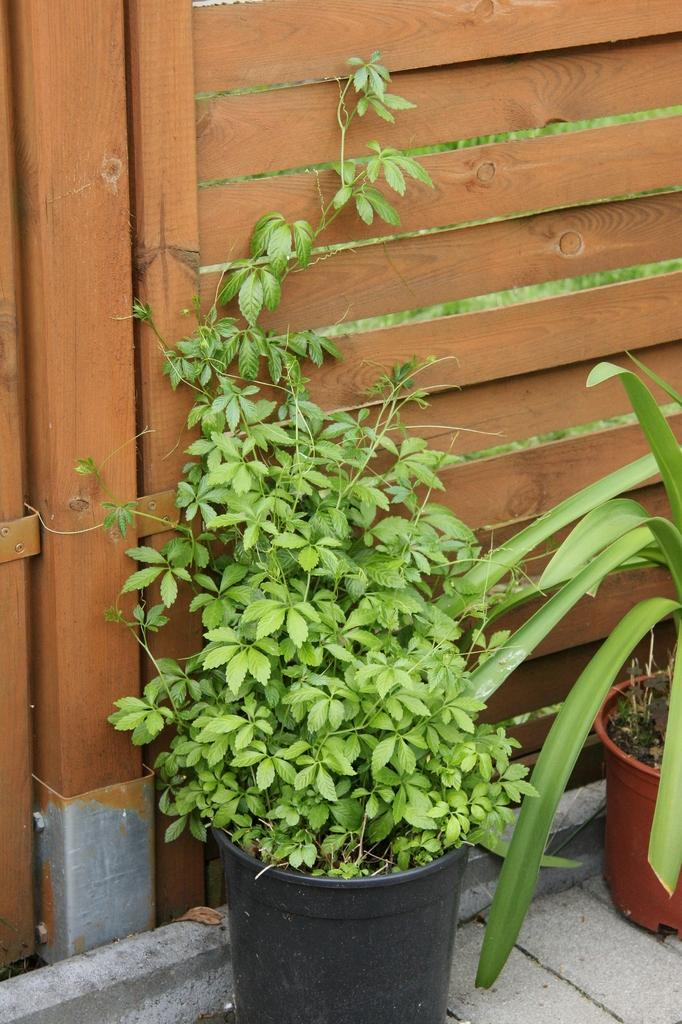What type of objects are in the pots in the image? There are plants in the pots in the image. Where are the plants placed? The plants are placed on a surface. What can be seen in the background of the image? There is a wooden fence visible on the backside of the image. What is the cause of the addition in the image? There is no addition or any indication of a cause in the image; it features plants in pots on a surface with a wooden fence in the background. 